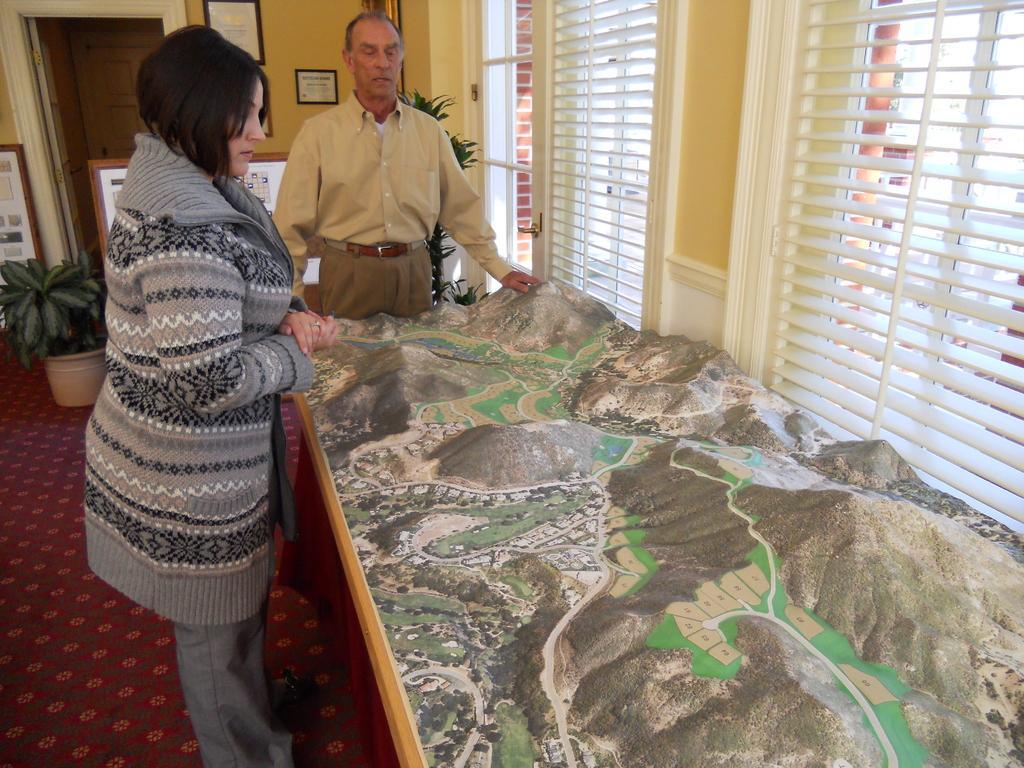How would you summarize this image in a sentence or two? In this image there is a woman and a man standing. In front of them there is a table. On the table there is a model. There are mountains and roads on the model. Beside the table there are windows to the wall. There are picture frames hanging on the wall. Behind them there are house plants and a door to the wall. There is a carpet on the floor. 